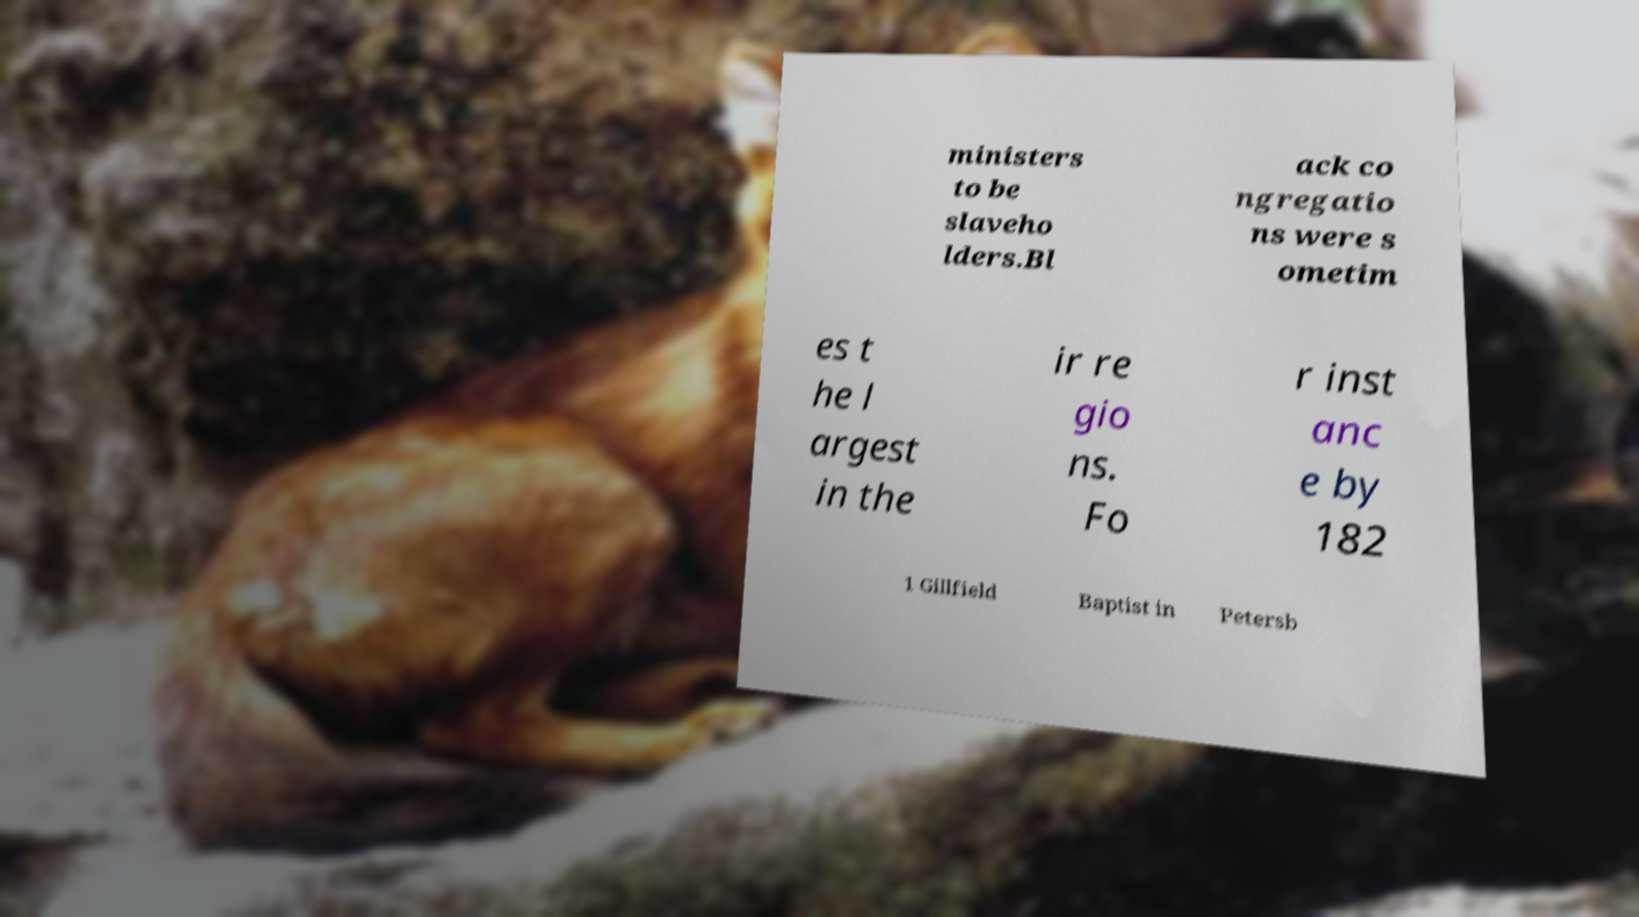Could you assist in decoding the text presented in this image and type it out clearly? ministers to be slaveho lders.Bl ack co ngregatio ns were s ometim es t he l argest in the ir re gio ns. Fo r inst anc e by 182 1 Gillfield Baptist in Petersb 